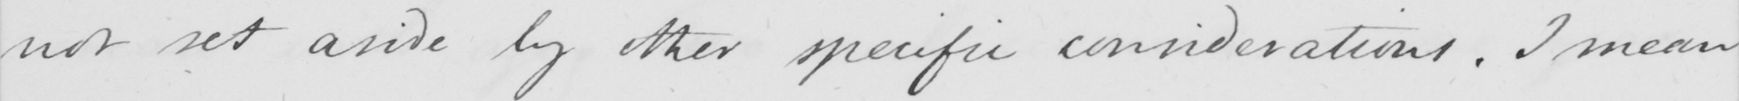What text is written in this handwritten line? not set aside by other specific considerations . I mean 